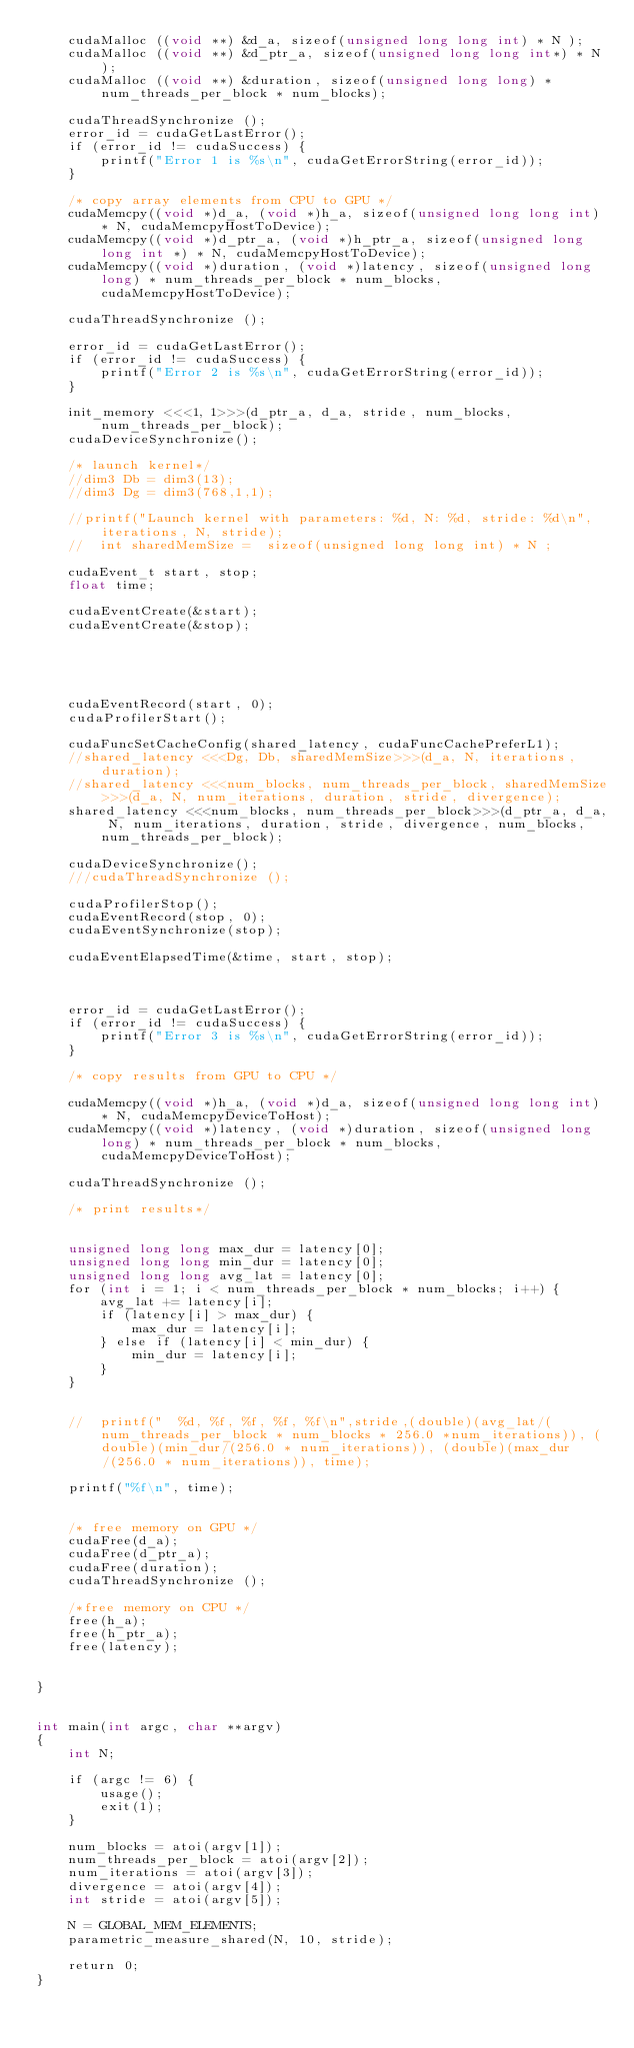Convert code to text. <code><loc_0><loc_0><loc_500><loc_500><_Cuda_>    cudaMalloc ((void **) &d_a, sizeof(unsigned long long int) * N );
    cudaMalloc ((void **) &d_ptr_a, sizeof(unsigned long long int*) * N );
    cudaMalloc ((void **) &duration, sizeof(unsigned long long) * num_threads_per_block * num_blocks);

    cudaThreadSynchronize ();
    error_id = cudaGetLastError();
    if (error_id != cudaSuccess) {
        printf("Error 1 is %s\n", cudaGetErrorString(error_id));
    }

    /* copy array elements from CPU to GPU */
    cudaMemcpy((void *)d_a, (void *)h_a, sizeof(unsigned long long int) * N, cudaMemcpyHostToDevice);
    cudaMemcpy((void *)d_ptr_a, (void *)h_ptr_a, sizeof(unsigned long long int *) * N, cudaMemcpyHostToDevice);
    cudaMemcpy((void *)duration, (void *)latency, sizeof(unsigned long long) * num_threads_per_block * num_blocks, cudaMemcpyHostToDevice);

    cudaThreadSynchronize ();

    error_id = cudaGetLastError();
    if (error_id != cudaSuccess) {
        printf("Error 2 is %s\n", cudaGetErrorString(error_id));
    }

    init_memory <<<1, 1>>>(d_ptr_a, d_a, stride, num_blocks, num_threads_per_block);
    cudaDeviceSynchronize();

    /* launch kernel*/
    //dim3 Db = dim3(13);
    //dim3 Dg = dim3(768,1,1);

    //printf("Launch kernel with parameters: %d, N: %d, stride: %d\n", iterations, N, stride);
    //	int sharedMemSize =  sizeof(unsigned long long int) * N ;

    cudaEvent_t start, stop;
    float time;

    cudaEventCreate(&start);
    cudaEventCreate(&stop);

    
    
    

    cudaEventRecord(start, 0);
    cudaProfilerStart();

    cudaFuncSetCacheConfig(shared_latency, cudaFuncCachePreferL1);
    //shared_latency <<<Dg, Db, sharedMemSize>>>(d_a, N, iterations, duration);
    //shared_latency <<<num_blocks, num_threads_per_block, sharedMemSize>>>(d_a, N, num_iterations, duration, stride, divergence);
    shared_latency <<<num_blocks, num_threads_per_block>>>(d_ptr_a, d_a, N, num_iterations, duration, stride, divergence, num_blocks, num_threads_per_block);

    cudaDeviceSynchronize();
    ///cudaThreadSynchronize ();

    cudaProfilerStop();
    cudaEventRecord(stop, 0);
    cudaEventSynchronize(stop);

    cudaEventElapsedTime(&time, start, stop);

    

    error_id = cudaGetLastError();
    if (error_id != cudaSuccess) {
        printf("Error 3 is %s\n", cudaGetErrorString(error_id));
    }

    /* copy results from GPU to CPU */

    cudaMemcpy((void *)h_a, (void *)d_a, sizeof(unsigned long long int) * N, cudaMemcpyDeviceToHost);
    cudaMemcpy((void *)latency, (void *)duration, sizeof(unsigned long long) * num_threads_per_block * num_blocks, cudaMemcpyDeviceToHost);

    cudaThreadSynchronize ();

    /* print results*/


    unsigned long long max_dur = latency[0];
    unsigned long long min_dur = latency[0];
    unsigned long long avg_lat = latency[0];
    for (int i = 1; i < num_threads_per_block * num_blocks; i++) {
        avg_lat += latency[i];
        if (latency[i] > max_dur) {
            max_dur = latency[i];
        } else if (latency[i] < min_dur) {
            min_dur = latency[i];
        }
    }


    //	printf("  %d, %f, %f, %f, %f\n",stride,(double)(avg_lat/(num_threads_per_block * num_blocks * 256.0 *num_iterations)), (double)(min_dur/(256.0 * num_iterations)), (double)(max_dur/(256.0 * num_iterations)), time);

    printf("%f\n", time);


    /* free memory on GPU */
    cudaFree(d_a);
    cudaFree(d_ptr_a);
    cudaFree(duration);
    cudaThreadSynchronize ();

    /*free memory on CPU */
    free(h_a);
    free(h_ptr_a);
    free(latency);


}


int main(int argc, char **argv)
{
    int N;

    if (argc != 6) {
        usage();
        exit(1);
    }

    num_blocks = atoi(argv[1]);
    num_threads_per_block = atoi(argv[2]);
    num_iterations = atoi(argv[3]);
    divergence = atoi(argv[4]);
    int stride = atoi(argv[5]);

    N = GLOBAL_MEM_ELEMENTS;
    parametric_measure_shared(N, 10, stride);

    return 0;
}
</code> 